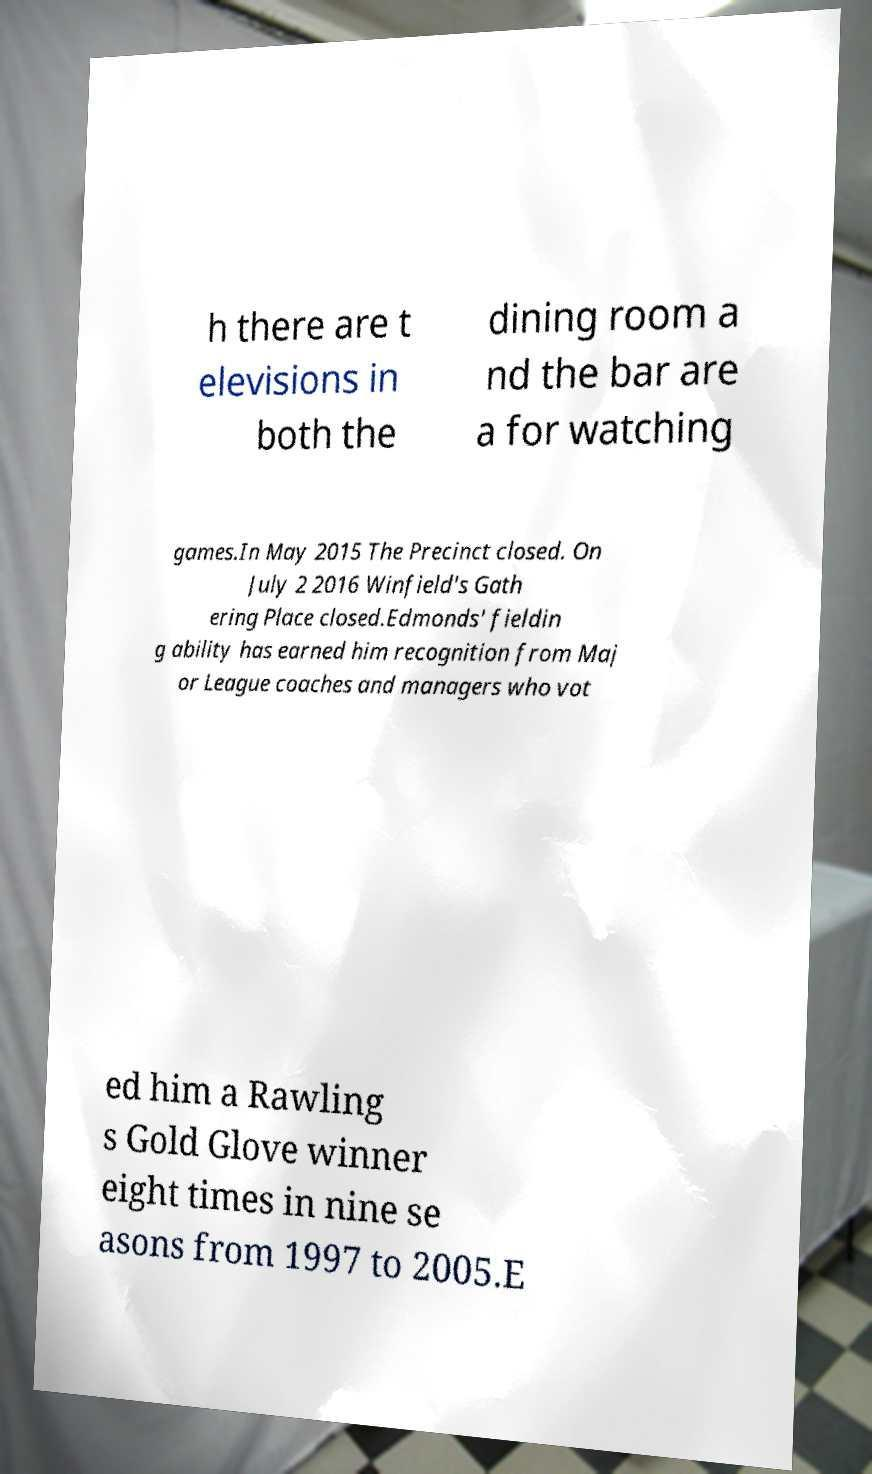For documentation purposes, I need the text within this image transcribed. Could you provide that? h there are t elevisions in both the dining room a nd the bar are a for watching games.In May 2015 The Precinct closed. On July 2 2016 Winfield's Gath ering Place closed.Edmonds' fieldin g ability has earned him recognition from Maj or League coaches and managers who vot ed him a Rawling s Gold Glove winner eight times in nine se asons from 1997 to 2005.E 